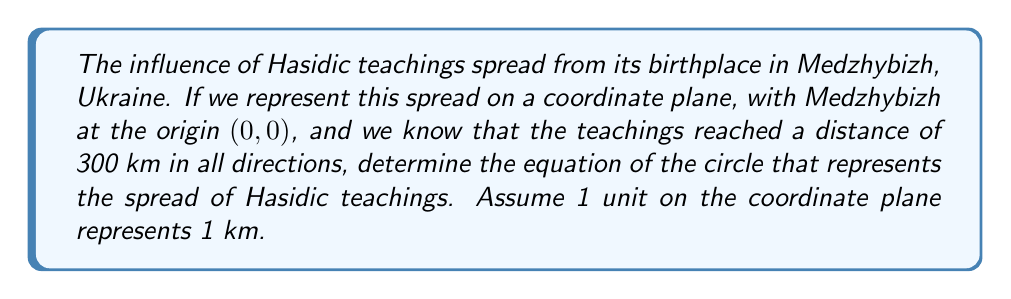Give your solution to this math problem. To solve this problem, we'll use the general equation of a circle:

$$(x - h)^2 + (y - k)^2 = r^2$$

Where $(h, k)$ is the center of the circle and $r$ is the radius.

Given information:
1. The center is at Medzhybizh, which is represented by the origin (0, 0).
2. The teachings spread 300 km in all directions, so the radius is 300 units.

Step 1: Identify the values for the equation
- Center: $(h, k) = (0, 0)$
- Radius: $r = 300$

Step 2: Substitute these values into the general equation
$$(x - 0)^2 + (y - 0)^2 = 300^2$$

Step 3: Simplify
$$x^2 + y^2 = 300^2$$
$$x^2 + y^2 = 90,000$$

This is the equation of the circle representing the spread of Hasidic teachings.

[asy]
import geometry;

size(200);
draw(circle((0,0), 300), blue);
dot((0,0));
label("Medzhybizh (0,0)", (0,0), SE);
draw((-350,0)--(350,0), arrow=Arrow);
draw((0,-350)--(0,350), arrow=Arrow);
label("x", (350,0), E);
label("y", (0,350), N);
[/asy]
Answer: $$x^2 + y^2 = 90,000$$ 